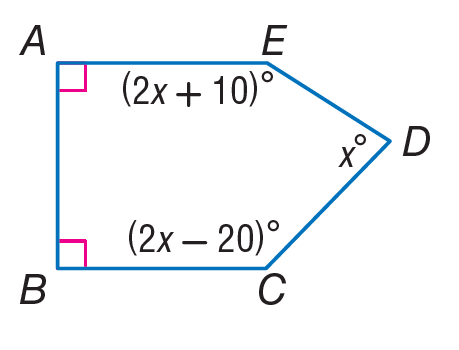Question: Find m \angle C.
Choices:
A. 38
B. 66
C. 72
D. 128
Answer with the letter. Answer: D Question: Find m \angle B.
Choices:
A. 90
B. 180
C. 270
D. 360
Answer with the letter. Answer: A Question: Find m \angle E.
Choices:
A. 38
B. 76
C. 79
D. 158
Answer with the letter. Answer: D Question: Find m \angle A.
Choices:
A. 45
B. 90
C. 180
D. 360
Answer with the letter. Answer: B Question: Find m \angle D.
Choices:
A. 36
B. 74
C. 78
D. 128
Answer with the letter. Answer: B 